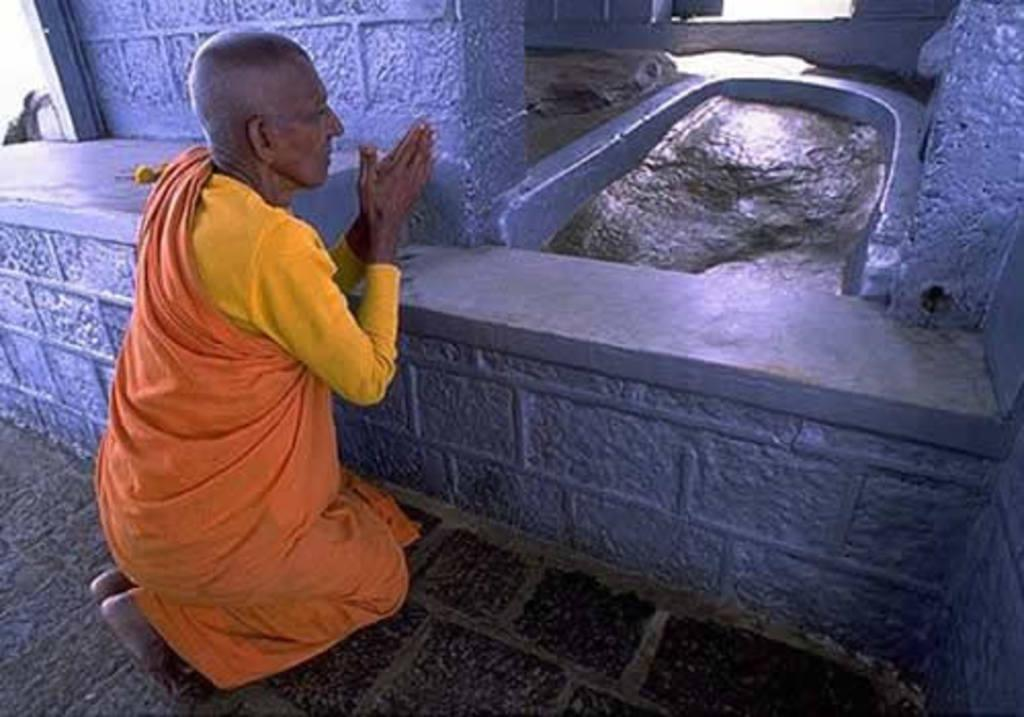Who is in the image? There is a person in the image. What is the person wearing? The person is wearing an orange dress. What position is the person in? The person is sitting on their knees. What activity is the person engaged in? The person is doing prayer. What type of curve can be seen on the side of the bucket in the image? There is no bucket present in the image, so it is not possible to answer that question. 